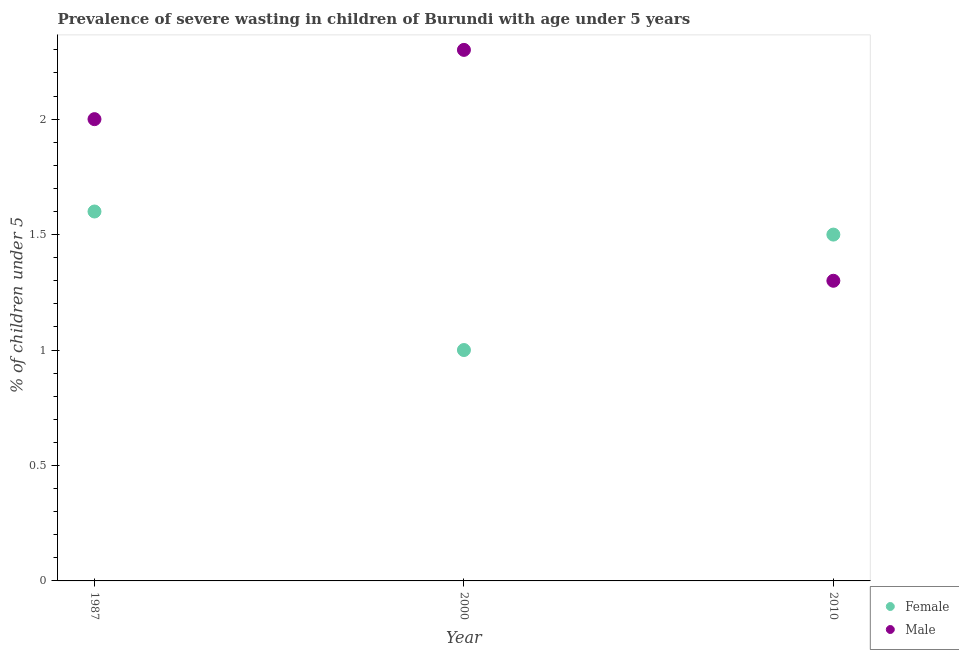Across all years, what is the maximum percentage of undernourished male children?
Ensure brevity in your answer.  2.3. Across all years, what is the minimum percentage of undernourished male children?
Your answer should be compact. 1.3. In which year was the percentage of undernourished female children maximum?
Provide a short and direct response. 1987. In which year was the percentage of undernourished female children minimum?
Make the answer very short. 2000. What is the total percentage of undernourished male children in the graph?
Offer a terse response. 5.6. What is the difference between the percentage of undernourished male children in 2000 and that in 2010?
Make the answer very short. 1. What is the difference between the percentage of undernourished female children in 1987 and the percentage of undernourished male children in 2000?
Offer a very short reply. -0.7. What is the average percentage of undernourished male children per year?
Ensure brevity in your answer.  1.87. In the year 1987, what is the difference between the percentage of undernourished male children and percentage of undernourished female children?
Provide a short and direct response. 0.4. In how many years, is the percentage of undernourished female children greater than 0.6 %?
Offer a terse response. 3. What is the ratio of the percentage of undernourished male children in 1987 to that in 2010?
Give a very brief answer. 1.54. Is the difference between the percentage of undernourished female children in 2000 and 2010 greater than the difference between the percentage of undernourished male children in 2000 and 2010?
Keep it short and to the point. No. What is the difference between the highest and the second highest percentage of undernourished female children?
Provide a succinct answer. 0.1. What is the difference between the highest and the lowest percentage of undernourished female children?
Provide a short and direct response. 0.6. In how many years, is the percentage of undernourished male children greater than the average percentage of undernourished male children taken over all years?
Make the answer very short. 2. Is the sum of the percentage of undernourished male children in 1987 and 2000 greater than the maximum percentage of undernourished female children across all years?
Keep it short and to the point. Yes. Does the percentage of undernourished female children monotonically increase over the years?
Keep it short and to the point. No. Is the percentage of undernourished female children strictly greater than the percentage of undernourished male children over the years?
Offer a very short reply. No. Is the percentage of undernourished female children strictly less than the percentage of undernourished male children over the years?
Give a very brief answer. No. How many dotlines are there?
Ensure brevity in your answer.  2. How many years are there in the graph?
Make the answer very short. 3. Are the values on the major ticks of Y-axis written in scientific E-notation?
Your answer should be compact. No. Does the graph contain any zero values?
Your response must be concise. No. Does the graph contain grids?
Your response must be concise. No. Where does the legend appear in the graph?
Your answer should be compact. Bottom right. What is the title of the graph?
Ensure brevity in your answer.  Prevalence of severe wasting in children of Burundi with age under 5 years. What is the label or title of the Y-axis?
Your answer should be very brief.  % of children under 5. What is the  % of children under 5 in Female in 1987?
Your answer should be very brief. 1.6. What is the  % of children under 5 in Male in 1987?
Provide a succinct answer. 2. What is the  % of children under 5 of Male in 2000?
Offer a very short reply. 2.3. What is the  % of children under 5 in Female in 2010?
Offer a terse response. 1.5. What is the  % of children under 5 of Male in 2010?
Give a very brief answer. 1.3. Across all years, what is the maximum  % of children under 5 of Female?
Your answer should be compact. 1.6. Across all years, what is the maximum  % of children under 5 in Male?
Your answer should be very brief. 2.3. Across all years, what is the minimum  % of children under 5 of Male?
Make the answer very short. 1.3. What is the difference between the  % of children under 5 of Female in 1987 and that in 2000?
Your answer should be very brief. 0.6. What is the difference between the  % of children under 5 in Male in 1987 and that in 2000?
Offer a terse response. -0.3. What is the difference between the  % of children under 5 in Female in 1987 and that in 2010?
Make the answer very short. 0.1. What is the difference between the  % of children under 5 of Male in 1987 and that in 2010?
Your answer should be compact. 0.7. What is the difference between the  % of children under 5 in Female in 2000 and that in 2010?
Provide a succinct answer. -0.5. What is the difference between the  % of children under 5 in Male in 2000 and that in 2010?
Provide a succinct answer. 1. What is the difference between the  % of children under 5 in Female in 1987 and the  % of children under 5 in Male in 2010?
Ensure brevity in your answer.  0.3. What is the average  % of children under 5 in Female per year?
Give a very brief answer. 1.37. What is the average  % of children under 5 of Male per year?
Offer a terse response. 1.87. In the year 1987, what is the difference between the  % of children under 5 of Female and  % of children under 5 of Male?
Your response must be concise. -0.4. In the year 2000, what is the difference between the  % of children under 5 in Female and  % of children under 5 in Male?
Offer a terse response. -1.3. In the year 2010, what is the difference between the  % of children under 5 in Female and  % of children under 5 in Male?
Offer a terse response. 0.2. What is the ratio of the  % of children under 5 of Male in 1987 to that in 2000?
Your answer should be compact. 0.87. What is the ratio of the  % of children under 5 in Female in 1987 to that in 2010?
Keep it short and to the point. 1.07. What is the ratio of the  % of children under 5 in Male in 1987 to that in 2010?
Provide a short and direct response. 1.54. What is the ratio of the  % of children under 5 of Female in 2000 to that in 2010?
Provide a short and direct response. 0.67. What is the ratio of the  % of children under 5 of Male in 2000 to that in 2010?
Ensure brevity in your answer.  1.77. 